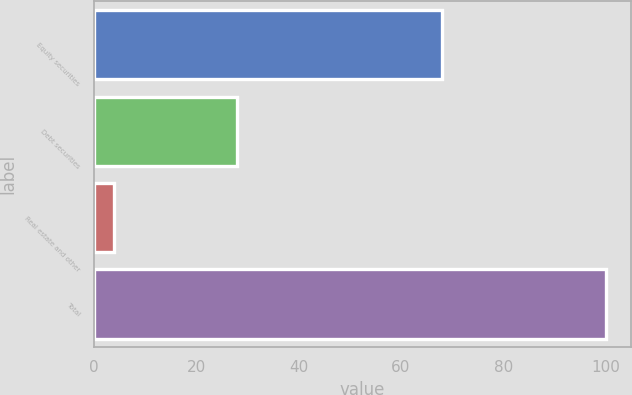<chart> <loc_0><loc_0><loc_500><loc_500><bar_chart><fcel>Equity securities<fcel>Debt securities<fcel>Real estate and other<fcel>Total<nl><fcel>68<fcel>28<fcel>4<fcel>100<nl></chart> 